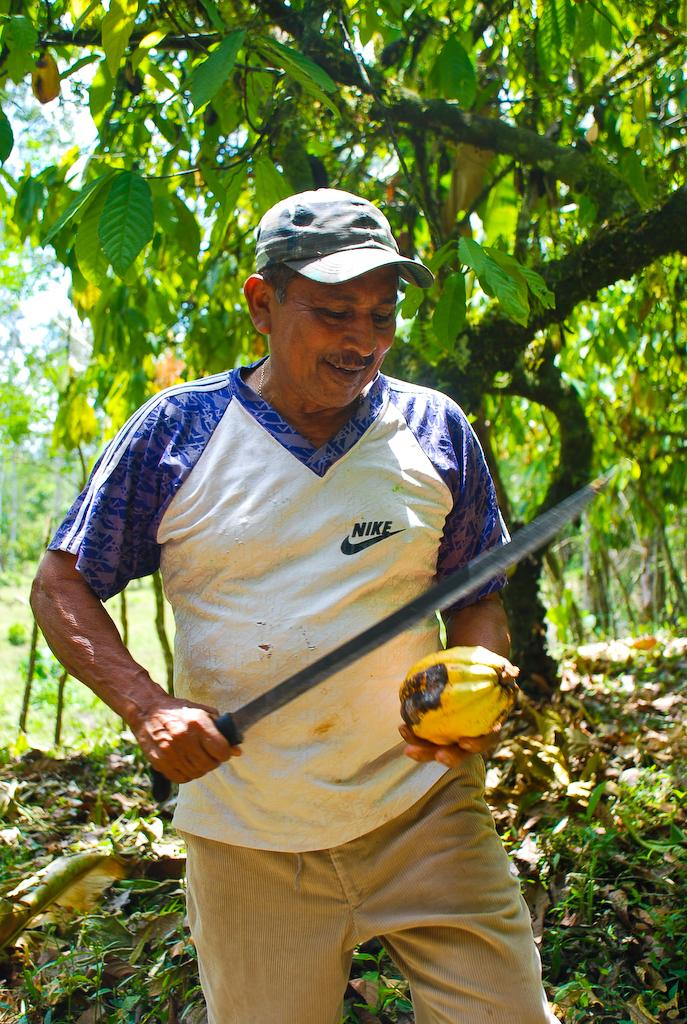What is the person in the image doing? The person is cutting a cocoa fruit. How is the person holding the cocoa fruit? The person is holding the cocoa fruit in their hands. What can be seen in the background of the image? There are trees and dry leaves visible in the background of the image. What type of curve can be seen in the image? There is no curve present in the image; it features a person cutting a cocoa fruit and a background with trees and dry leaves. Is there a match being played in the image? There is no match or volleyball game present in the image. 